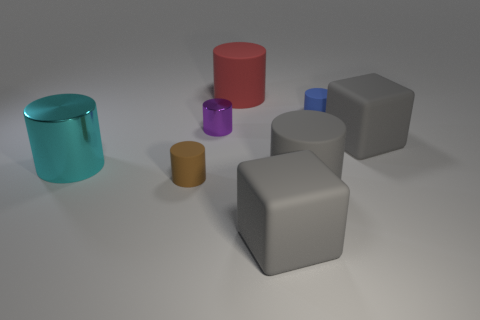There is a purple cylinder; is its size the same as the gray cube that is on the right side of the large gray matte cylinder?
Offer a terse response. No. There is a brown cylinder that is the same material as the tiny blue thing; what size is it?
Offer a very short reply. Small. What size is the blue cylinder that is behind the gray matte cube in front of the brown object?
Provide a short and direct response. Small. There is a matte thing that is left of the purple shiny cylinder; is it the same size as the large red object?
Provide a short and direct response. No. Is there a brown sphere of the same size as the gray cylinder?
Provide a short and direct response. No. There is a shiny thing that is in front of the big gray block that is behind the big cube that is left of the blue cylinder; what is its shape?
Ensure brevity in your answer.  Cylinder. Is the number of large gray things that are in front of the cyan object greater than the number of large purple matte blocks?
Offer a very short reply. Yes. Is there another large cyan object that has the same shape as the large cyan thing?
Give a very brief answer. No. Are the big cyan thing and the purple cylinder on the right side of the big metal cylinder made of the same material?
Provide a succinct answer. Yes. What color is the tiny metallic cylinder?
Provide a short and direct response. Purple. 